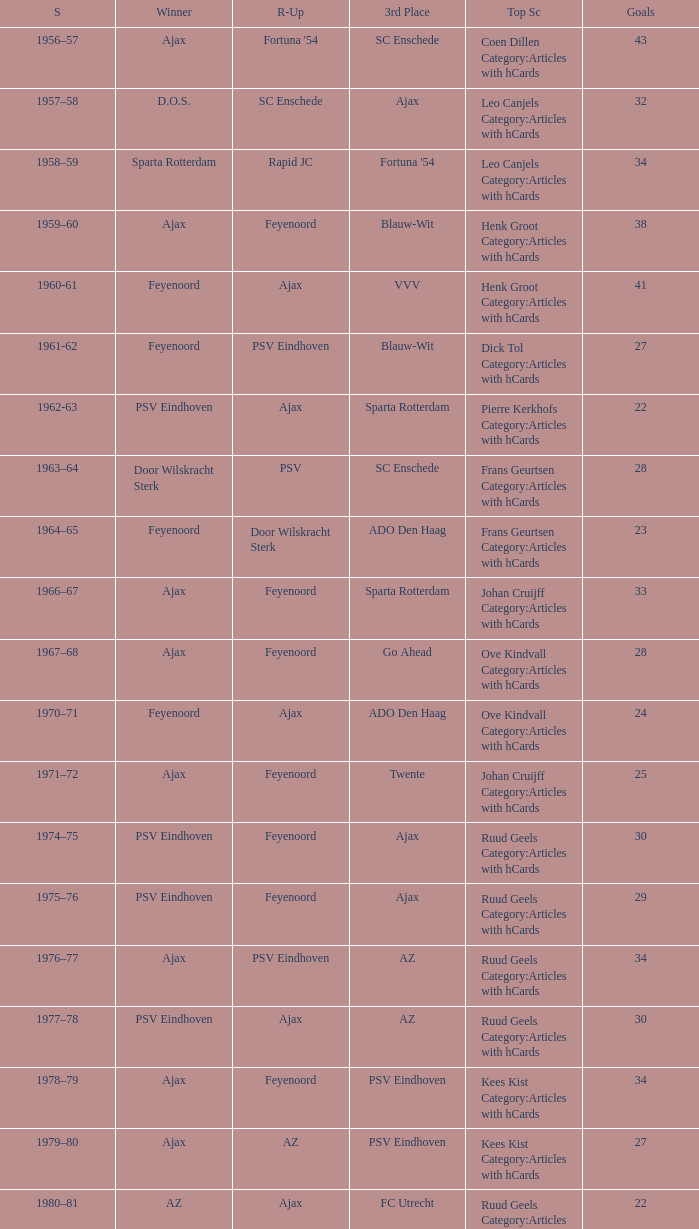I'm looking to parse the entire table for insights. Could you assist me with that? {'header': ['S', 'Winner', 'R-Up', '3rd Place', 'Top Sc', 'Goals'], 'rows': [['1956–57', 'Ajax', "Fortuna '54", 'SC Enschede', 'Coen Dillen Category:Articles with hCards', '43'], ['1957–58', 'D.O.S.', 'SC Enschede', 'Ajax', 'Leo Canjels Category:Articles with hCards', '32'], ['1958–59', 'Sparta Rotterdam', 'Rapid JC', "Fortuna '54", 'Leo Canjels Category:Articles with hCards', '34'], ['1959–60', 'Ajax', 'Feyenoord', 'Blauw-Wit', 'Henk Groot Category:Articles with hCards', '38'], ['1960-61', 'Feyenoord', 'Ajax', 'VVV', 'Henk Groot Category:Articles with hCards', '41'], ['1961-62', 'Feyenoord', 'PSV Eindhoven', 'Blauw-Wit', 'Dick Tol Category:Articles with hCards', '27'], ['1962-63', 'PSV Eindhoven', 'Ajax', 'Sparta Rotterdam', 'Pierre Kerkhofs Category:Articles with hCards', '22'], ['1963–64', 'Door Wilskracht Sterk', 'PSV', 'SC Enschede', 'Frans Geurtsen Category:Articles with hCards', '28'], ['1964–65', 'Feyenoord', 'Door Wilskracht Sterk', 'ADO Den Haag', 'Frans Geurtsen Category:Articles with hCards', '23'], ['1966–67', 'Ajax', 'Feyenoord', 'Sparta Rotterdam', 'Johan Cruijff Category:Articles with hCards', '33'], ['1967–68', 'Ajax', 'Feyenoord', 'Go Ahead', 'Ove Kindvall Category:Articles with hCards', '28'], ['1970–71', 'Feyenoord', 'Ajax', 'ADO Den Haag', 'Ove Kindvall Category:Articles with hCards', '24'], ['1971–72', 'Ajax', 'Feyenoord', 'Twente', 'Johan Cruijff Category:Articles with hCards', '25'], ['1974–75', 'PSV Eindhoven', 'Feyenoord', 'Ajax', 'Ruud Geels Category:Articles with hCards', '30'], ['1975–76', 'PSV Eindhoven', 'Feyenoord', 'Ajax', 'Ruud Geels Category:Articles with hCards', '29'], ['1976–77', 'Ajax', 'PSV Eindhoven', 'AZ', 'Ruud Geels Category:Articles with hCards', '34'], ['1977–78', 'PSV Eindhoven', 'Ajax', 'AZ', 'Ruud Geels Category:Articles with hCards', '30'], ['1978–79', 'Ajax', 'Feyenoord', 'PSV Eindhoven', 'Kees Kist Category:Articles with hCards', '34'], ['1979–80', 'Ajax', 'AZ', 'PSV Eindhoven', 'Kees Kist Category:Articles with hCards', '27'], ['1980–81', 'AZ', 'Ajax', 'FC Utrecht', 'Ruud Geels Category:Articles with hCards', '22'], ['1981-82', 'Ajax', 'PSV Eindhoven', 'AZ', 'Wim Kieft Category:Articles with hCards', '32'], ['1982-83', 'Ajax', 'Feyenoord', 'PSV Eindhoven', 'Peter Houtman Category:Articles with hCards', '30'], ['1983-84', 'Feyenoord', 'PSV Eindhoven', 'Ajax', 'Marco van Basten Category:Articles with hCards', '28'], ['1984-85', 'Ajax', 'PSV Eindhoven', 'Feyenoord', 'Marco van Basten Category:Articles with hCards', '22'], ['1985-86', 'PSV Eindhoven', 'Ajax', 'Feyenoord', 'Marco van Basten Category:Articles with hCards', '37'], ['1986-87', 'PSV Eindhoven', 'Ajax', 'Feyenoord', 'Marco van Basten Category:Articles with hCards', '31'], ['1987-88', 'PSV Eindhoven', 'Ajax', 'Twente', 'Wim Kieft Category:Articles with hCards', '29'], ['1988–89', 'PSV Eindhoven', 'Ajax', 'Twente', 'Romário', '19'], ['1989-90', 'Ajax', 'PSV Eindhoven', 'Twente', 'Romário', '23'], ['1990–91', 'PSV Eindhoven', 'Ajax', 'FC Groningen', 'Romário Dennis Bergkamp', '25'], ['1991–92', 'PSV Eindhoven', 'Ajax', 'Feyenoord', 'Dennis Bergkamp Category:Articles with hCards', '22'], ['1992–93', 'Feyenoord', 'PSV Eindhoven', 'Ajax', 'Dennis Bergkamp Category:Articles with hCards', '26'], ['1993–94', 'Ajax', 'Feyenoord', 'PSV Eindhoven', 'Jari Litmanen Category:Articles with hCards', '26'], ['1994–95', 'Ajax', 'Roda JC', 'PSV Eindhoven', 'Ronaldo', '30'], ['1995–96', 'Ajax', 'PSV Eindhoven', 'Feyenoord', 'Luc Nilis Category:Articles with hCards', '21'], ['1996–97', 'PSV Eindhoven', 'Feyenoord', 'Twente', 'Luc Nilis Category:Articles with hCards', '21'], ['1997–98', 'Ajax', 'PSV Eindhoven', 'Vitesse', 'Nikos Machlas Category:Articles with hCards', '34'], ['1998–99', 'Feyenoord', 'Willem II', 'PSV Eindhoven', 'Ruud van Nistelrooy Category:Articles with hCards', '31'], ['1999–2000', 'PSV Eindhoven', 'Heerenveen', 'Feyenoord', 'Ruud van Nistelrooy Category:Articles with hCards', '29'], ['2000–01', 'PSV Eindhoven', 'Feyenoord', 'Ajax', 'Mateja Kežman Category:Articles with hCards', '24'], ['2001–02', 'Ajax', 'PSV Eindhoven', 'Feyenoord', 'Pierre van Hooijdonk Category:Articles with hCards', '24'], ['2002-03', 'PSV Eindhoven', 'Ajax', 'Feyenoord', 'Mateja Kežman Category:Articles with hCards', '35'], ['2003-04', 'Ajax', 'PSV Eindhoven', 'Feyenoord', 'Mateja Kežman Category:Articles with hCards', '31'], ['2004-05', 'PSV Eindhoven', 'Ajax', 'AZ', 'Dirk Kuyt Category:Articles with hCards', '29'], ['2005-06', 'PSV Eindhoven', 'AZ', 'Feyenoord', 'Klaas-Jan Huntelaar Category:Articles with hCards', '33'], ['2006-07', 'PSV Eindhoven', 'Ajax', 'AZ', 'Afonso Alves Category:Articles with hCards', '34'], ['2007-08', 'PSV Eindhoven', 'Ajax', 'NAC Breda', 'Klaas-Jan Huntelaar Category:Articles with hCards', '33'], ['2008-09', 'AZ', 'Twente', 'Ajax', 'Mounir El Hamdaoui Category:Articles with hCards', '23'], ['2009-10', 'Twente', 'Ajax', 'PSV Eindhoven', 'Luis Suárez Category:Articles with hCards', '35'], ['2010-11', 'Ajax', 'Twente', 'PSV Eindhoven', 'Björn Vleminckx Category:Articles with hCards', '23'], ['2011-12', 'Ajax', 'Feyenoord', 'PSV Eindhoven', 'Bas Dost Category:Articles with hCards', '32']]} When twente came in third place and ajax was the winner what are the seasons? 1971–72, 1989-90. 